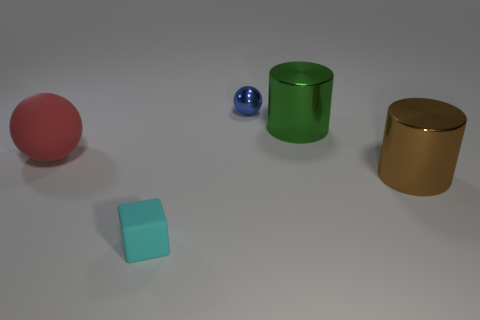Add 4 big brown things. How many objects exist? 9 Subtract all cubes. How many objects are left? 4 Subtract 2 cylinders. How many cylinders are left? 0 Subtract all brown cylinders. How many cylinders are left? 1 Subtract all small cyan rubber objects. Subtract all large things. How many objects are left? 1 Add 1 matte balls. How many matte balls are left? 2 Add 4 tiny cyan cubes. How many tiny cyan cubes exist? 5 Subtract 0 green cubes. How many objects are left? 5 Subtract all blue cylinders. Subtract all cyan spheres. How many cylinders are left? 2 Subtract all green spheres. How many purple cubes are left? 0 